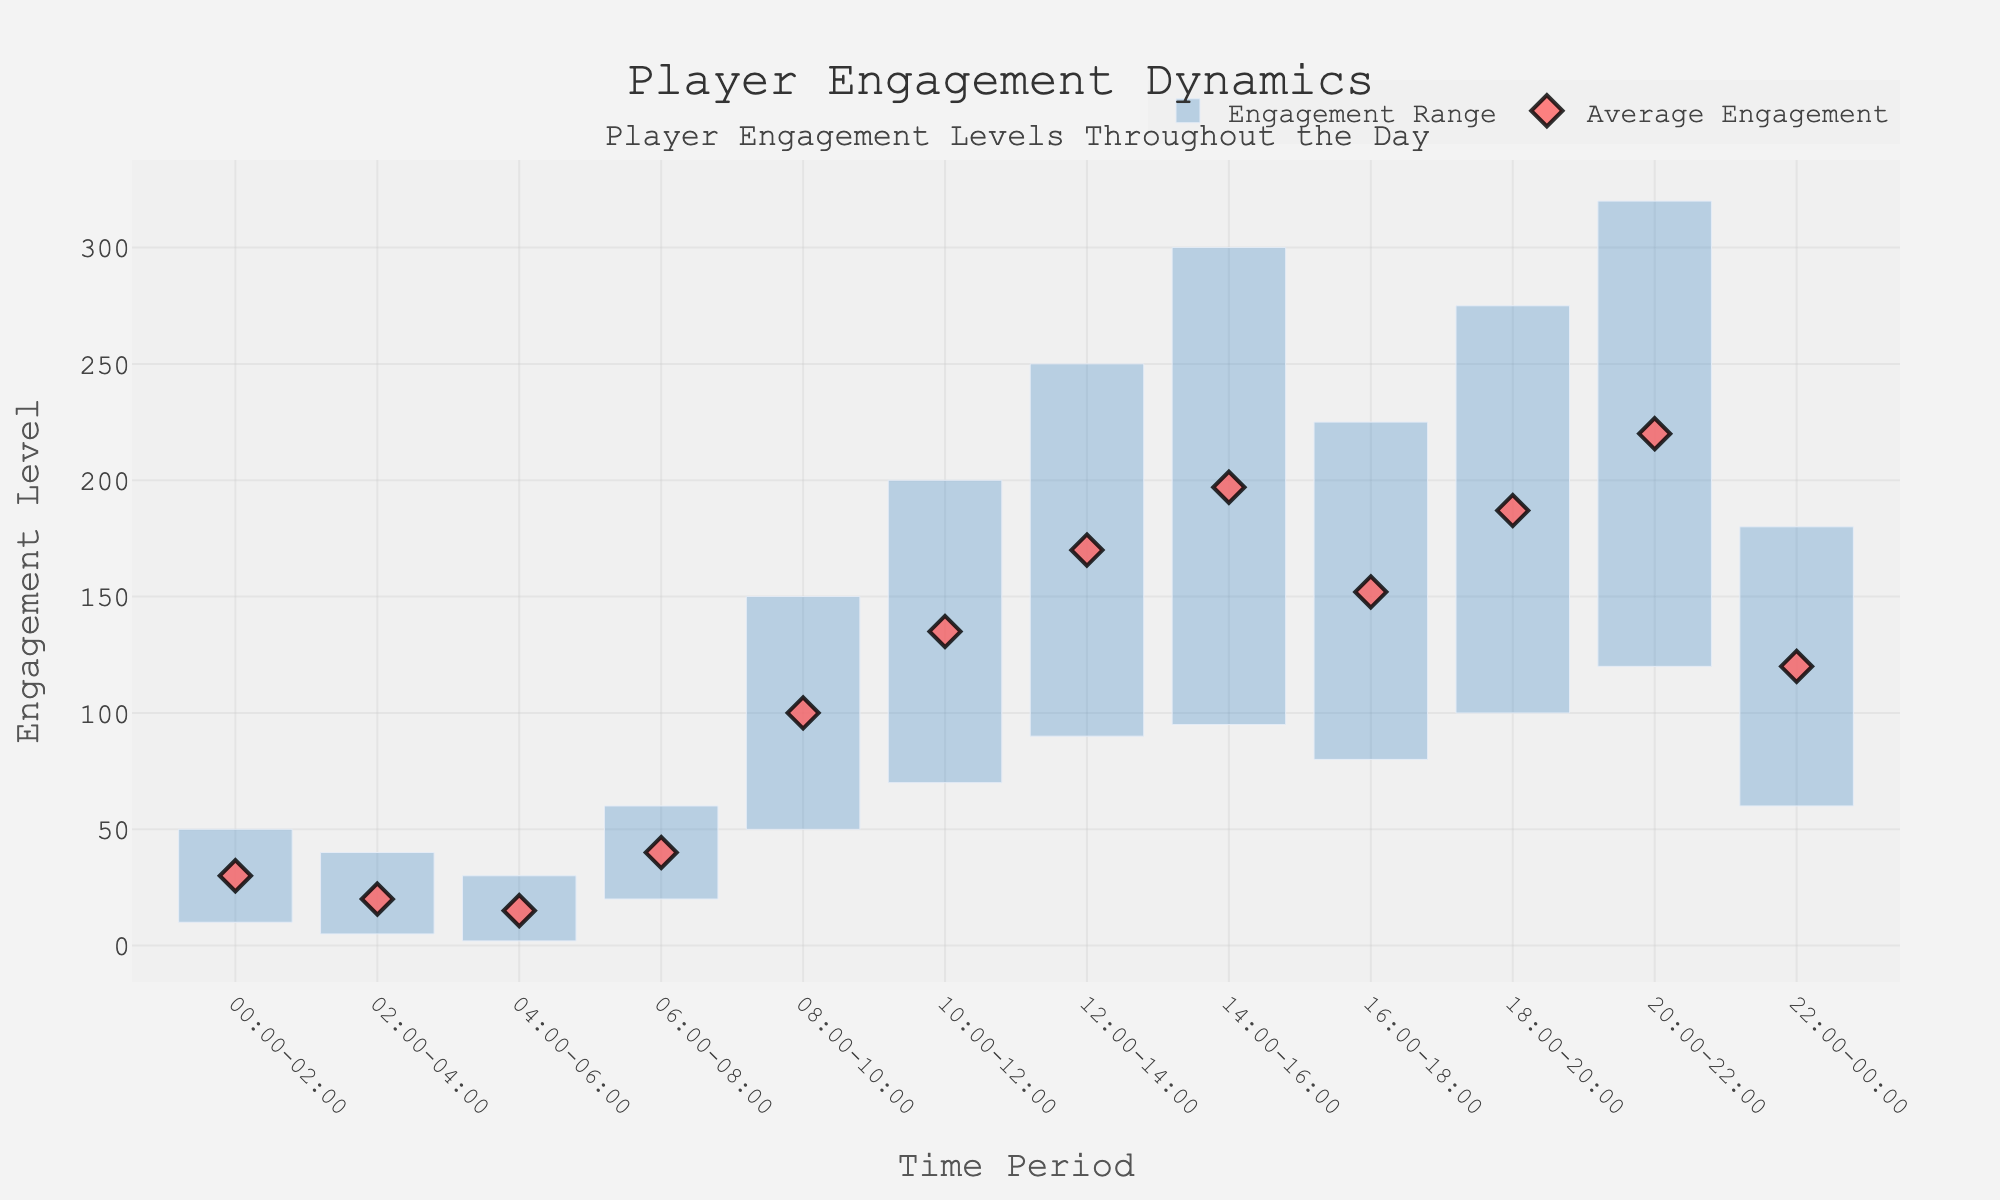what is the title of the plot? The title of the plot is provided at the top-center of the figure, usually in larger and bold text to catch the viewer's attention. By looking at the plot, the title "Player Engagement Dynamics" can be seen, indicating the focus of the data.
Answer: Player Engagement Dynamics What is the average engagement for the time period 06:00-08:00? The figure displays average engagement points as markers on each time period. By locating the time period 06:00-08:00 on the x-axis and checking the corresponding point, it shows the average engagement marked.
Answer: 40 What is the time period with the highest maximum engagement? The highest maximum engagement can be identified by the tallest top of the engagement range bars. By scanning vertically, the highest top is at the time period 20:00-22:00.
Answer: 20:00-22:00 Between which two consecutive time periods is the increase in average engagement the greatest? To find the highest increase in average engagement, examine the difference between average engagement points across consecutive time periods. Calculate the differences and compare them. The largest increase is between 22:00-00:00 and 00:00-02:00 (30 - 120), between 00:00-02:00 and 02:00-04:00 (30 - 20), and so on. The greatest positive difference is between 04:00-06:00 and 06:00-08:00 (40 - 15).
Answer: 06:00-08:00 and 08:00-10:00 What is the time period with the smallest range of engagement? The range of engagement for each time period is represented by the height of the bars. Check for the smallest height from the base to the top. The time period with the smallest height is 04:00-06:00 (30 - 2).
Answer: 04:00-06:00 Which time period has a higher average engagement, 16:00-18:00 or 18:00-20:00? Compare the average engagement points for the time periods 16:00-18:00 and 18:00-20:00 on the plot. The point for 16:00-18:00 is at 152, and for 18:00-20:00 is at 187. 187 is higher than 152.
Answer: 18:00-20:00 What is the average engagement level for all periods combined? Calculate the overall average engagement by summing up all individual average engagement values and dividing by the total number of periods. (30 + 20 + 15 + 40 + 100 + 135 + 170 + 197 + 152 + 187 + 220 + 120) / 12 = 144.25
Answer: 144.25 During which time period does the engagement NEVER drop below 60? To find when engagement never drops below 60, look for the time periods where the lower bound of the engagement range is above 60. This observation satisfies during 08:00-10:00 and all succeeding periods.
Answer: 08:00-10:00 What is the most common symbol used for indicating average engagement? The average engagement markers are represented by a specific symbol in the plot. By examining, the markers appear as diamonds.
Answer: Diamond 